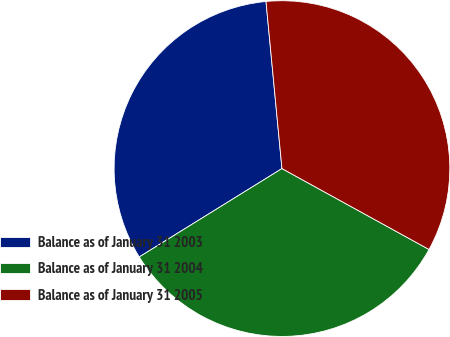Convert chart. <chart><loc_0><loc_0><loc_500><loc_500><pie_chart><fcel>Balance as of January 31 2003<fcel>Balance as of January 31 2004<fcel>Balance as of January 31 2005<nl><fcel>32.31%<fcel>33.17%<fcel>34.52%<nl></chart> 